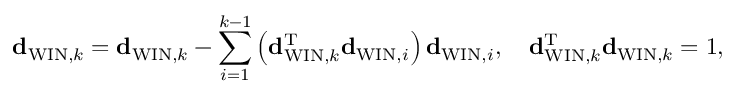<formula> <loc_0><loc_0><loc_500><loc_500>{ d } _ { W I N , k } = { d } _ { W I N , k } - \sum _ { i = 1 } ^ { k - 1 } \left ( { d } _ { W I N , k } ^ { T } { d } _ { W I N , i } \right ) { d } _ { W I N , i } , \quad d _ { W I N , k } ^ { T } { d } _ { W I N , k } = 1 ,</formula> 